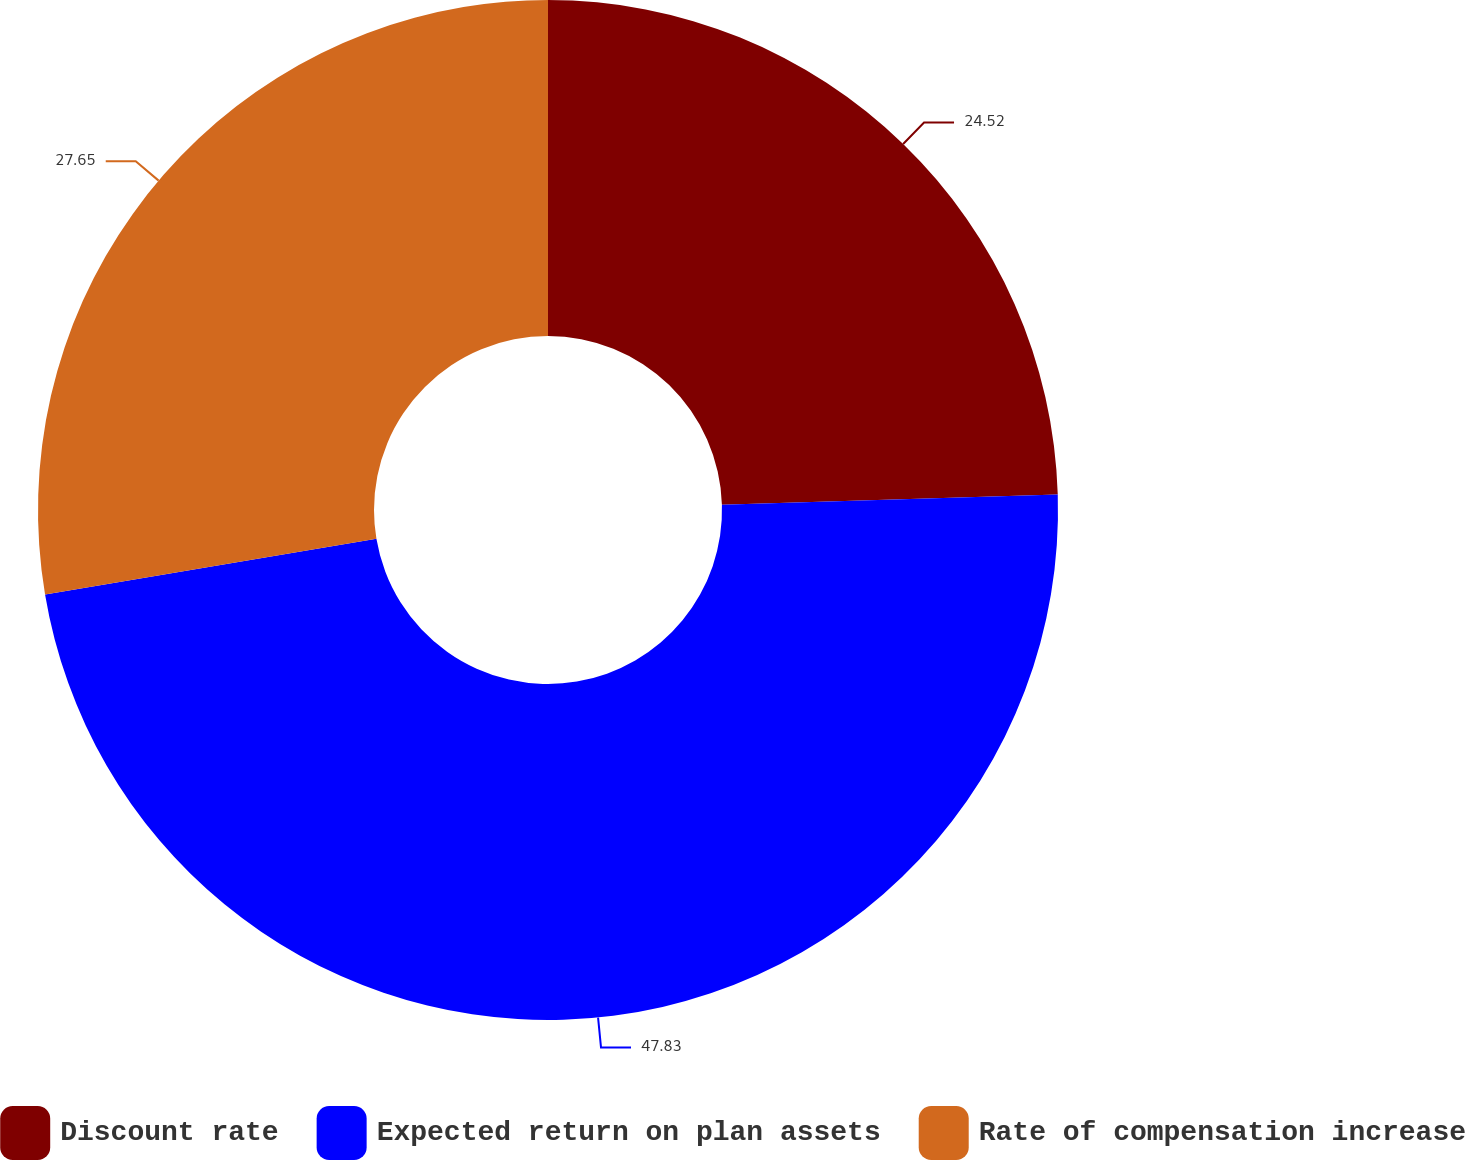<chart> <loc_0><loc_0><loc_500><loc_500><pie_chart><fcel>Discount rate<fcel>Expected return on plan assets<fcel>Rate of compensation increase<nl><fcel>24.52%<fcel>47.83%<fcel>27.65%<nl></chart> 